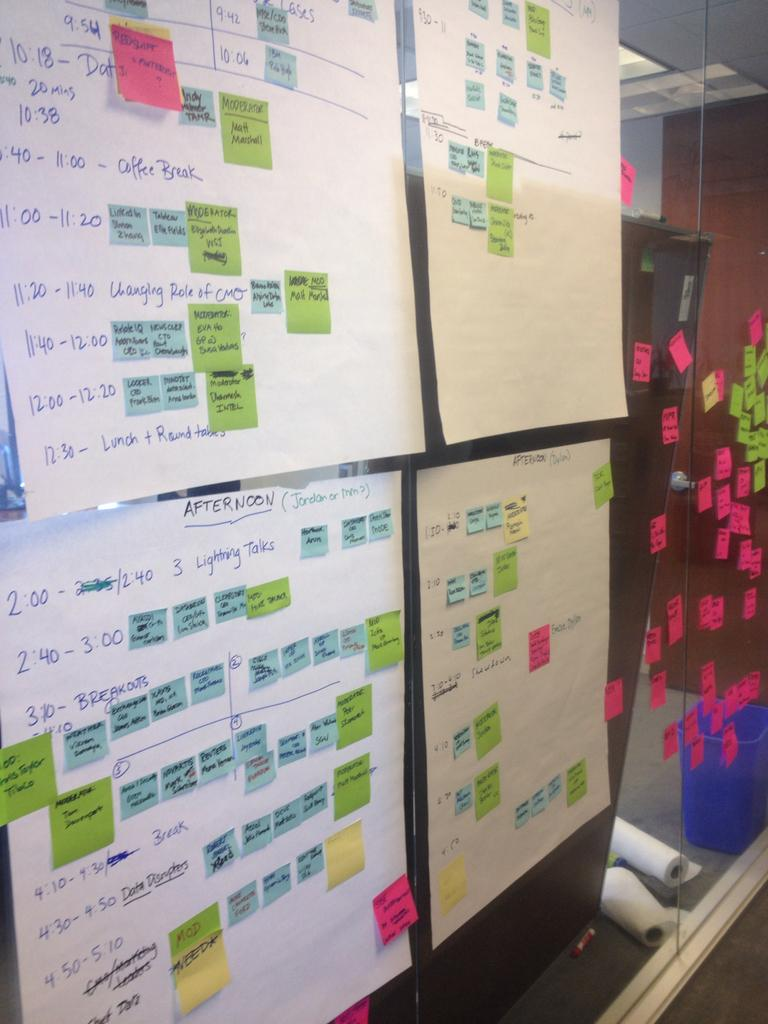<image>
Provide a brief description of the given image. A schedule poster board of the breakdown of the afternoon which includes lightning talks among other sticky notes. 